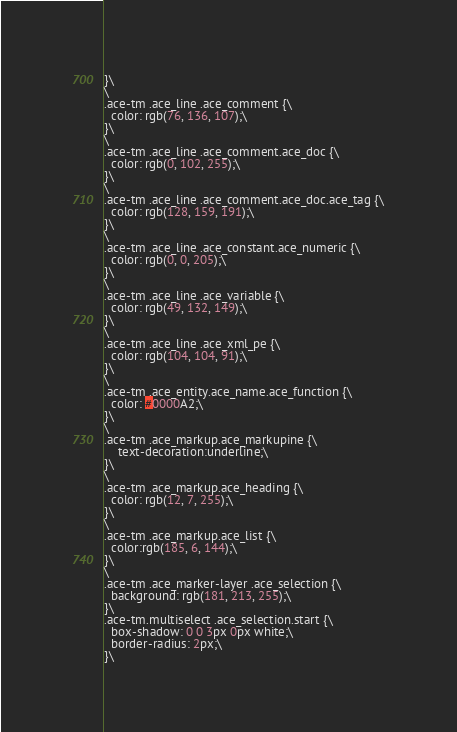<code> <loc_0><loc_0><loc_500><loc_500><_JavaScript_>}\
\
.ace-tm .ace_line .ace_comment {\
  color: rgb(76, 136, 107);\
}\
\
.ace-tm .ace_line .ace_comment.ace_doc {\
  color: rgb(0, 102, 255);\
}\
\
.ace-tm .ace_line .ace_comment.ace_doc.ace_tag {\
  color: rgb(128, 159, 191);\
}\
\
.ace-tm .ace_line .ace_constant.ace_numeric {\
  color: rgb(0, 0, 205);\
}\
\
.ace-tm .ace_line .ace_variable {\
  color: rgb(49, 132, 149);\
}\
\
.ace-tm .ace_line .ace_xml_pe {\
  color: rgb(104, 104, 91);\
}\
\
.ace-tm .ace_entity.ace_name.ace_function {\
  color: #0000A2;\
}\
\
.ace-tm .ace_markup.ace_markupine {\
    text-decoration:underline;\
}\
\
.ace-tm .ace_markup.ace_heading {\
  color: rgb(12, 7, 255);\
}\
\
.ace-tm .ace_markup.ace_list {\
  color:rgb(185, 6, 144);\
}\
\
.ace-tm .ace_marker-layer .ace_selection {\
  background: rgb(181, 213, 255);\
}\
.ace-tm.multiselect .ace_selection.start {\
  box-shadow: 0 0 3px 0px white;\
  border-radius: 2px;\
}\</code> 